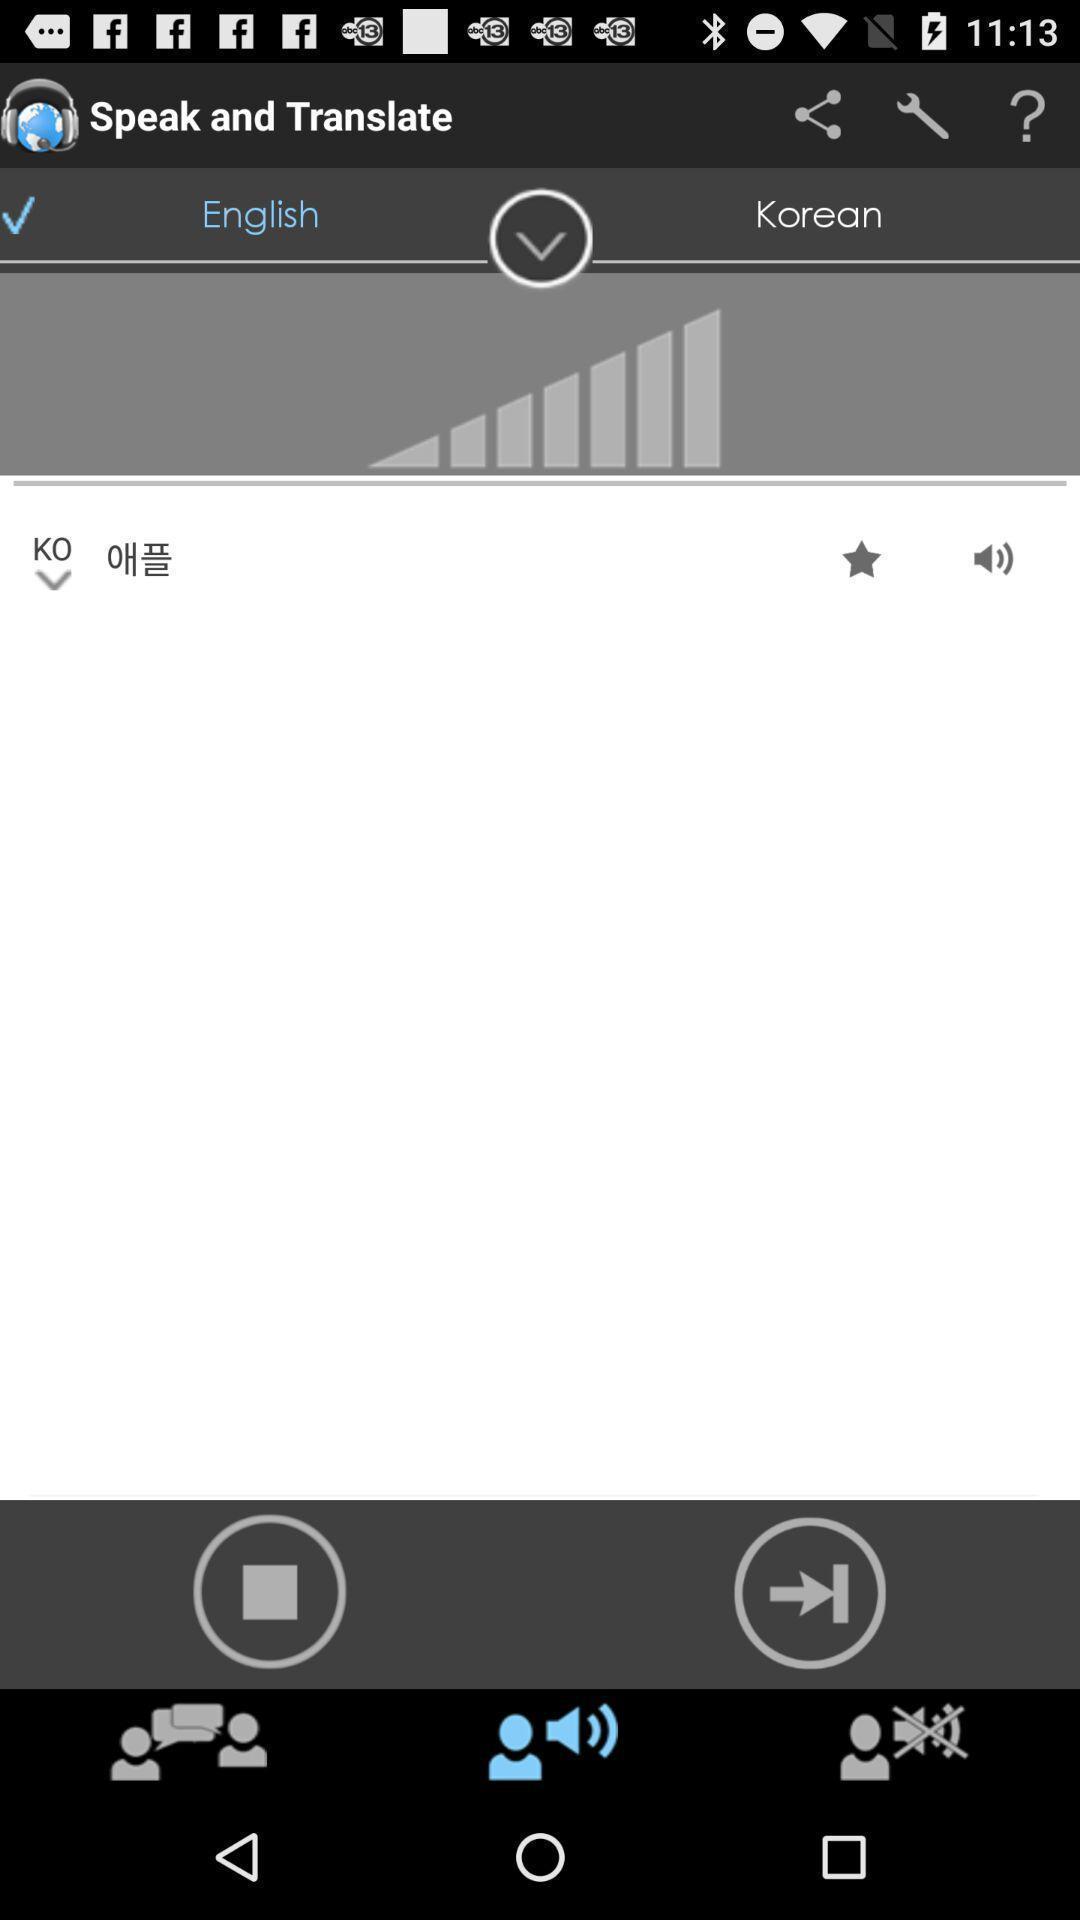Give me a summary of this screen capture. Translation page. 